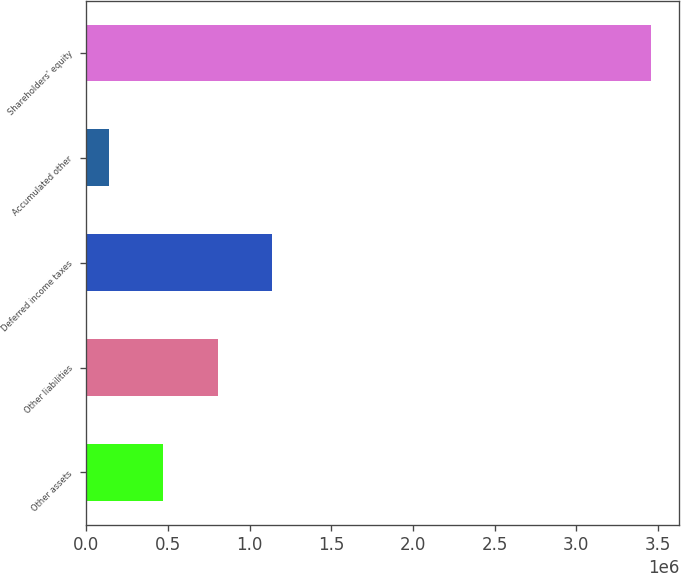Convert chart. <chart><loc_0><loc_0><loc_500><loc_500><bar_chart><fcel>Other assets<fcel>Other liabilities<fcel>Deferred income taxes<fcel>Accumulated other<fcel>Shareholders' equity<nl><fcel>472007<fcel>803916<fcel>1.13583e+06<fcel>140097<fcel>3.45919e+06<nl></chart> 